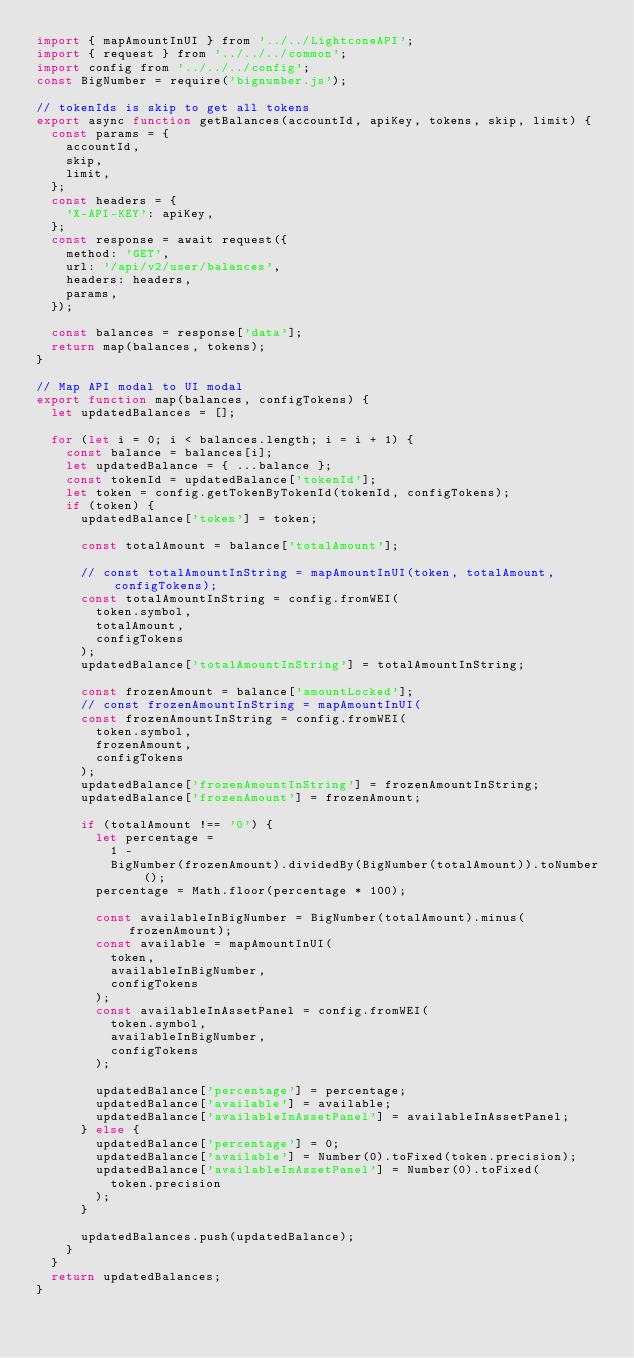Convert code to text. <code><loc_0><loc_0><loc_500><loc_500><_JavaScript_>import { mapAmountInUI } from '../../LightconeAPI';
import { request } from '../../../common';
import config from '../../../config';
const BigNumber = require('bignumber.js');

// tokenIds is skip to get all tokens
export async function getBalances(accountId, apiKey, tokens, skip, limit) {
  const params = {
    accountId,
    skip,
    limit,
  };
  const headers = {
    'X-API-KEY': apiKey,
  };
  const response = await request({
    method: 'GET',
    url: '/api/v2/user/balances',
    headers: headers,
    params,
  });

  const balances = response['data'];
  return map(balances, tokens);
}

// Map API modal to UI modal
export function map(balances, configTokens) {
  let updatedBalances = [];

  for (let i = 0; i < balances.length; i = i + 1) {
    const balance = balances[i];
    let updatedBalance = { ...balance };
    const tokenId = updatedBalance['tokenId'];
    let token = config.getTokenByTokenId(tokenId, configTokens);
    if (token) {
      updatedBalance['token'] = token;

      const totalAmount = balance['totalAmount'];

      // const totalAmountInString = mapAmountInUI(token, totalAmount, configTokens);
      const totalAmountInString = config.fromWEI(
        token.symbol,
        totalAmount,
        configTokens
      );
      updatedBalance['totalAmountInString'] = totalAmountInString;

      const frozenAmount = balance['amountLocked'];
      // const frozenAmountInString = mapAmountInUI(
      const frozenAmountInString = config.fromWEI(
        token.symbol,
        frozenAmount,
        configTokens
      );
      updatedBalance['frozenAmountInString'] = frozenAmountInString;
      updatedBalance['frozenAmount'] = frozenAmount;

      if (totalAmount !== '0') {
        let percentage =
          1 -
          BigNumber(frozenAmount).dividedBy(BigNumber(totalAmount)).toNumber();
        percentage = Math.floor(percentage * 100);

        const availableInBigNumber = BigNumber(totalAmount).minus(frozenAmount);
        const available = mapAmountInUI(
          token,
          availableInBigNumber,
          configTokens
        );
        const availableInAssetPanel = config.fromWEI(
          token.symbol,
          availableInBigNumber,
          configTokens
        );

        updatedBalance['percentage'] = percentage;
        updatedBalance['available'] = available;
        updatedBalance['availableInAssetPanel'] = availableInAssetPanel;
      } else {
        updatedBalance['percentage'] = 0;
        updatedBalance['available'] = Number(0).toFixed(token.precision);
        updatedBalance['availableInAssetPanel'] = Number(0).toFixed(
          token.precision
        );
      }

      updatedBalances.push(updatedBalance);
    }
  }
  return updatedBalances;
}
</code> 